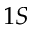Convert formula to latex. <formula><loc_0><loc_0><loc_500><loc_500>1 S</formula> 